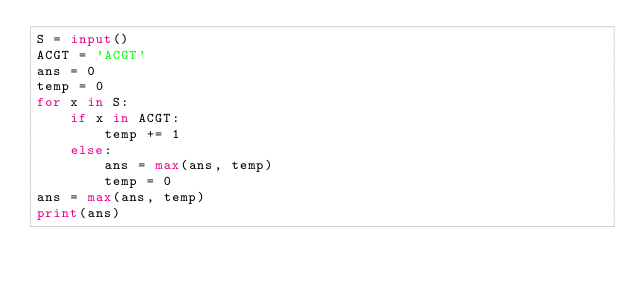<code> <loc_0><loc_0><loc_500><loc_500><_Python_>S = input()
ACGT = 'ACGT'
ans = 0
temp = 0
for x in S:
    if x in ACGT:
        temp += 1
    else:
        ans = max(ans, temp)
        temp = 0
ans = max(ans, temp)
print(ans)</code> 